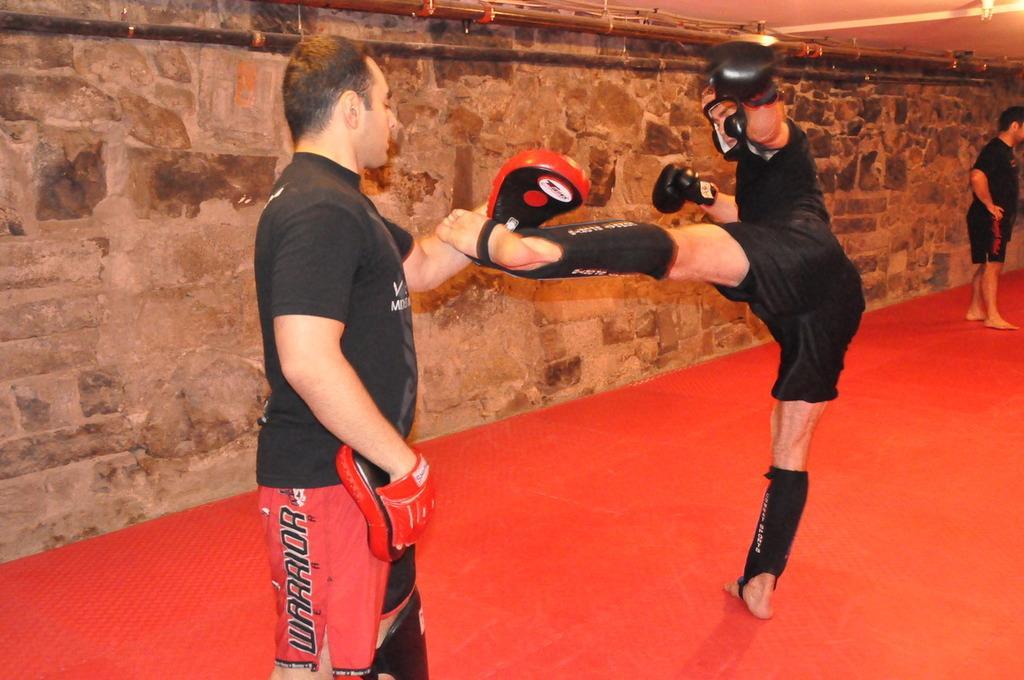Can you describe this image briefly? In the picture I can see people are standing on a red color floor. The man in the middle is wearing some objects. In the background I can see a wall and ceiling. 